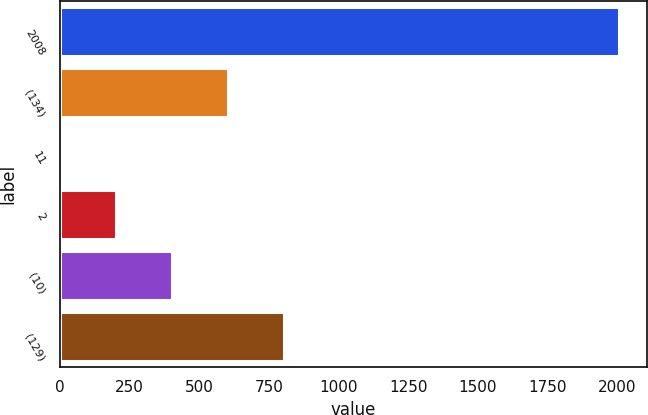Convert chart. <chart><loc_0><loc_0><loc_500><loc_500><bar_chart><fcel>2008<fcel>(134)<fcel>11<fcel>2<fcel>(10)<fcel>(129)<nl><fcel>2006<fcel>603.06<fcel>1.8<fcel>202.22<fcel>402.64<fcel>803.48<nl></chart> 